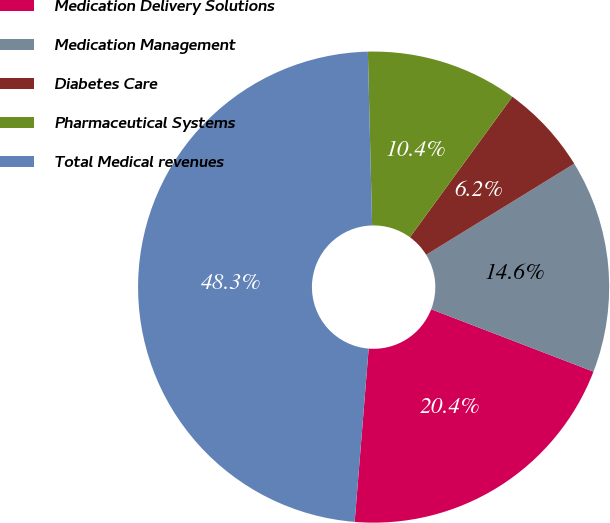<chart> <loc_0><loc_0><loc_500><loc_500><pie_chart><fcel>Medication Delivery Solutions<fcel>Medication Management<fcel>Diabetes Care<fcel>Pharmaceutical Systems<fcel>Total Medical revenues<nl><fcel>20.44%<fcel>14.62%<fcel>6.2%<fcel>10.41%<fcel>48.33%<nl></chart> 